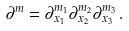<formula> <loc_0><loc_0><loc_500><loc_500>\partial ^ { m } = \partial ^ { m _ { 1 } } _ { x _ { 1 } } \partial ^ { m _ { 2 } } _ { x _ { 2 } } \partial ^ { m _ { 3 } } _ { x _ { 3 } } \, .</formula> 